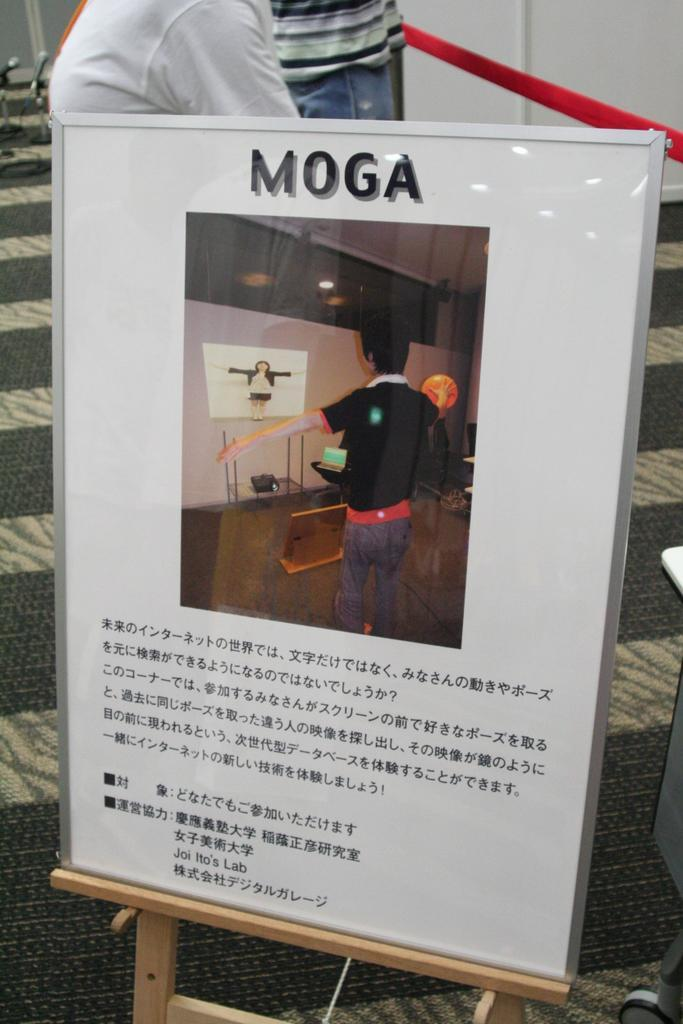What is on the board that is visible in the image? There is a board with a picture and letter on it in the image. How many people are in the image? There are two people standing in the image. What color is the thread that is visible in the image? There is a red thread in the image. What is on the floor in the image? There is a carpet on the floor in the image. How many ladybugs are crawling on the carpet in the image? There are no ladybugs present in the image; it only features a board with a picture and letter, two people, a red thread, and a carpet. Are there any bikes or balls visible in the image? No, there are no bikes or balls present in the image. 